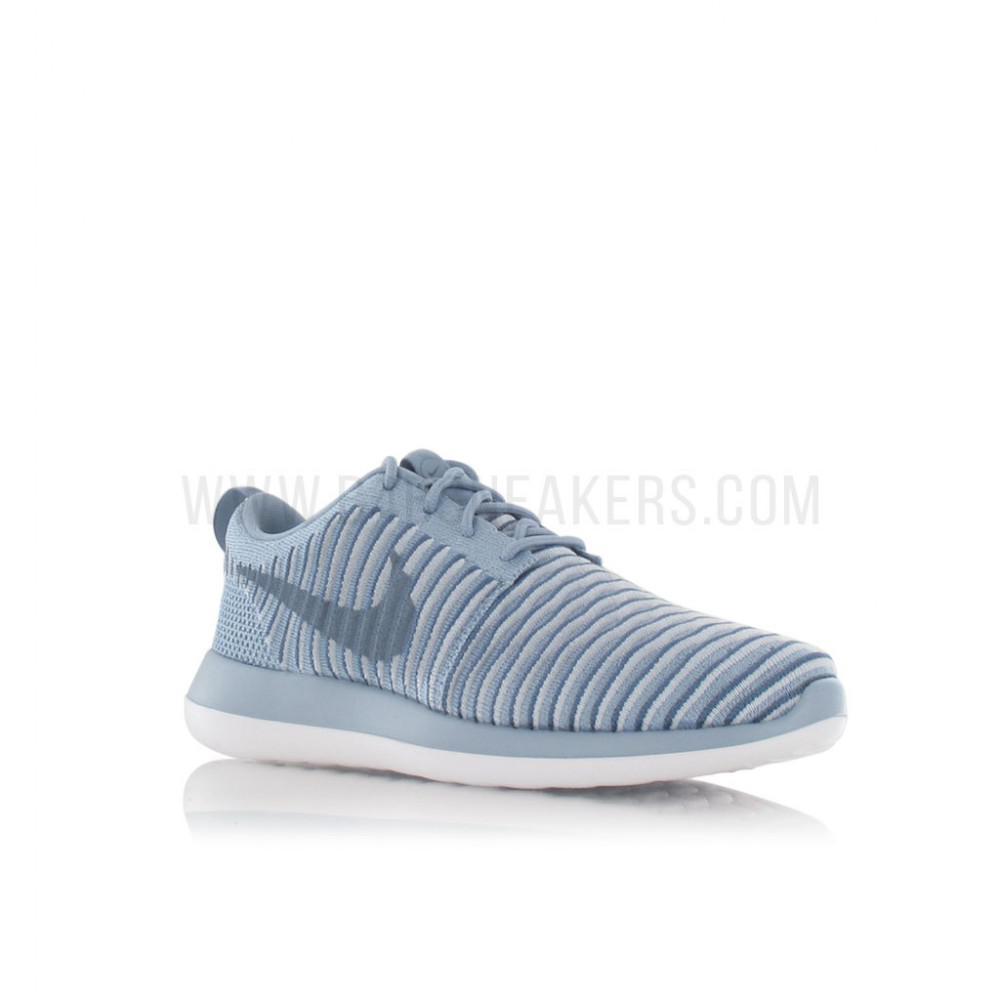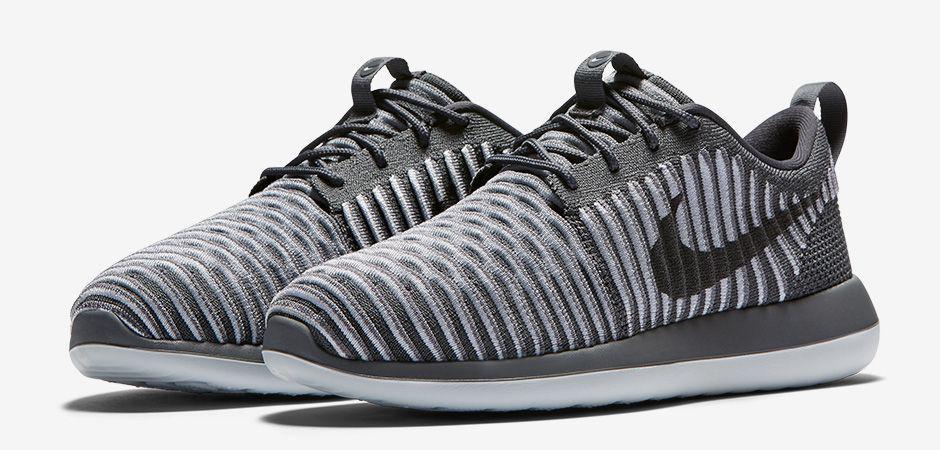The first image is the image on the left, the second image is the image on the right. Given the left and right images, does the statement "A pair of shoes, side by side, in one image is a varigated stripe design with a different weave on the heel area and two-toned soles, while a second image shows just one shoe of a similar design, but in a different color." hold true? Answer yes or no. Yes. The first image is the image on the left, the second image is the image on the right. For the images shown, is this caption "An image contains at least one green sports shoe." true? Answer yes or no. No. 